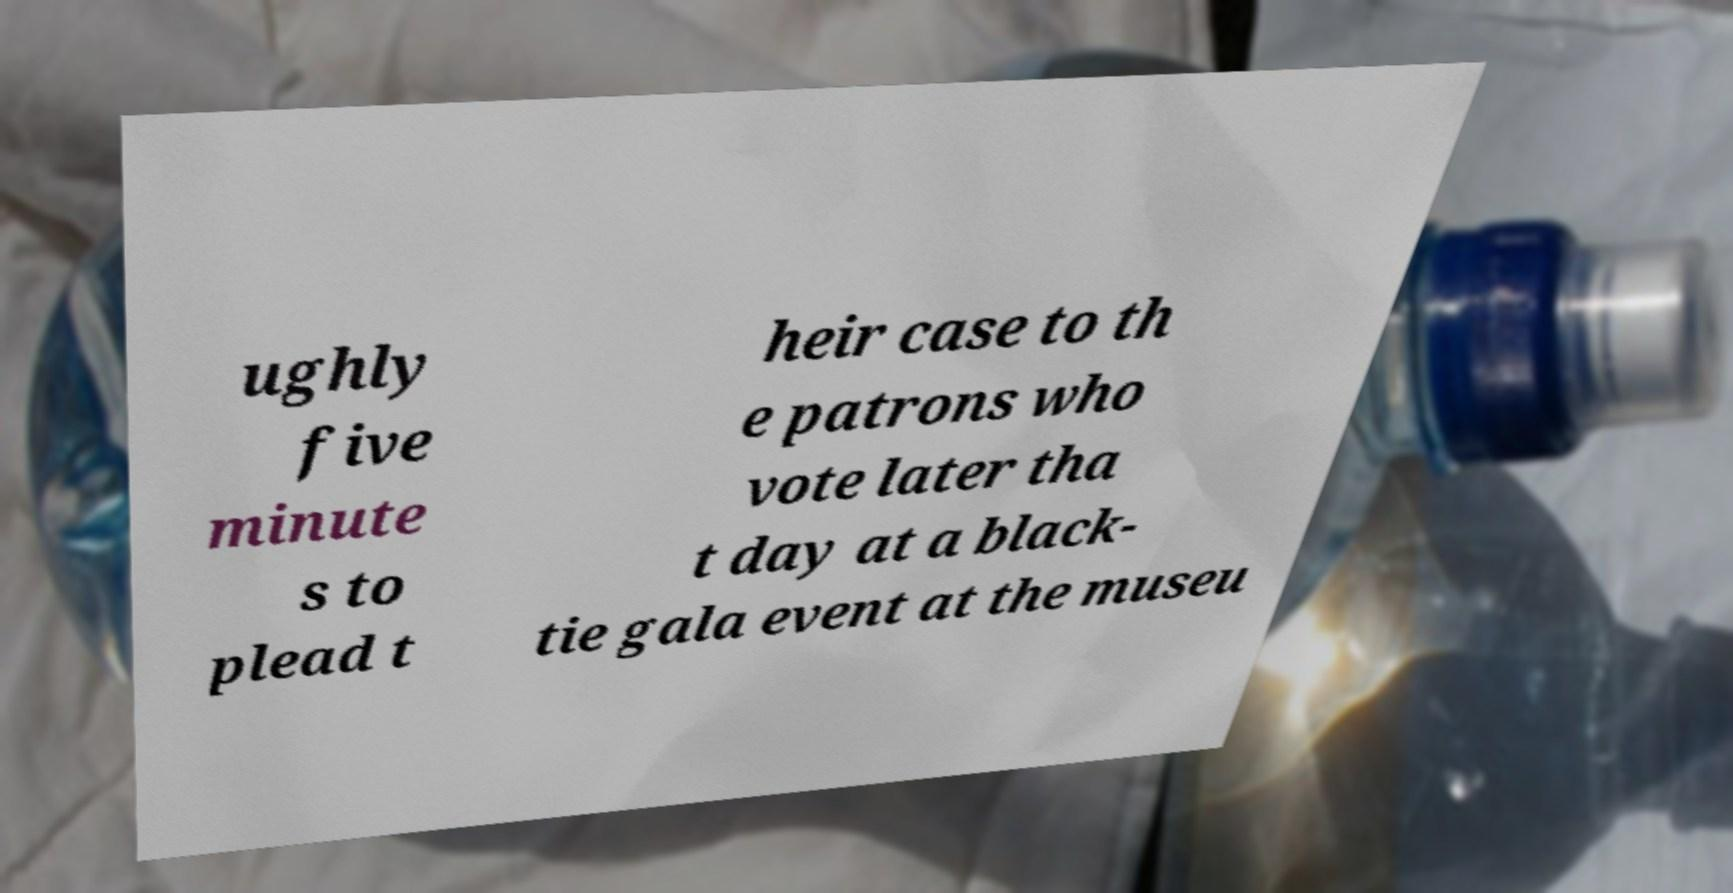Could you assist in decoding the text presented in this image and type it out clearly? ughly five minute s to plead t heir case to th e patrons who vote later tha t day at a black- tie gala event at the museu 